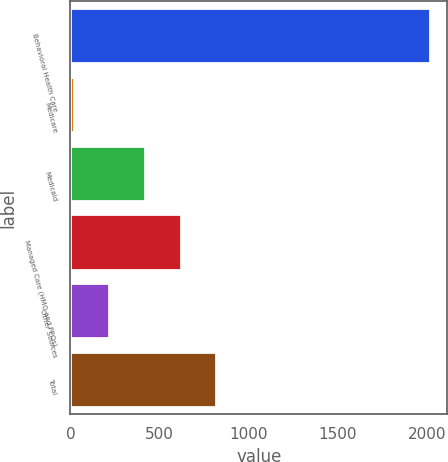Convert chart. <chart><loc_0><loc_0><loc_500><loc_500><bar_chart><fcel>Behavioral Health Care<fcel>Medicare<fcel>Medicaid<fcel>Managed Care (HMO and PPOs)<fcel>Other Sources<fcel>Total<nl><fcel>2013<fcel>19<fcel>417.8<fcel>617.2<fcel>218.4<fcel>816.6<nl></chart> 